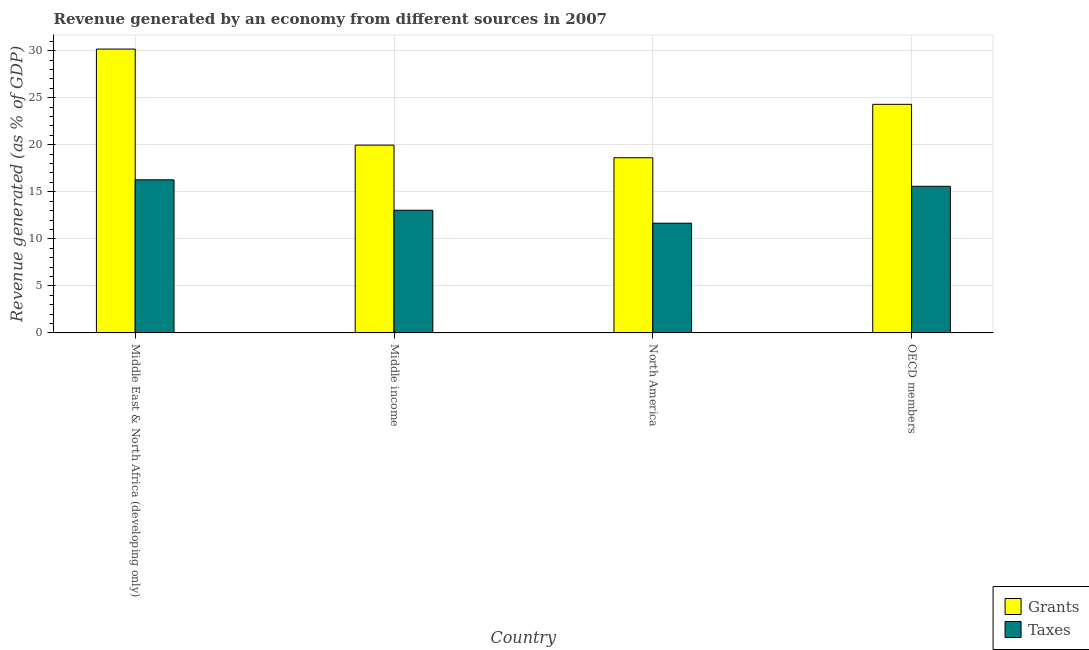How many bars are there on the 2nd tick from the right?
Make the answer very short. 2. In how many cases, is the number of bars for a given country not equal to the number of legend labels?
Ensure brevity in your answer.  0. What is the revenue generated by taxes in North America?
Offer a very short reply. 11.66. Across all countries, what is the maximum revenue generated by grants?
Make the answer very short. 30.17. Across all countries, what is the minimum revenue generated by grants?
Provide a succinct answer. 18.62. In which country was the revenue generated by grants maximum?
Your answer should be compact. Middle East & North Africa (developing only). What is the total revenue generated by taxes in the graph?
Give a very brief answer. 56.56. What is the difference between the revenue generated by taxes in North America and that in OECD members?
Give a very brief answer. -3.92. What is the difference between the revenue generated by grants in OECD members and the revenue generated by taxes in Middle East & North Africa (developing only)?
Offer a very short reply. 8.02. What is the average revenue generated by grants per country?
Your response must be concise. 23.26. What is the difference between the revenue generated by taxes and revenue generated by grants in OECD members?
Your answer should be very brief. -8.71. What is the ratio of the revenue generated by taxes in Middle income to that in North America?
Provide a short and direct response. 1.12. What is the difference between the highest and the second highest revenue generated by grants?
Your answer should be very brief. 5.87. What is the difference between the highest and the lowest revenue generated by grants?
Your answer should be compact. 11.55. Is the sum of the revenue generated by grants in Middle East & North Africa (developing only) and Middle income greater than the maximum revenue generated by taxes across all countries?
Offer a terse response. Yes. What does the 2nd bar from the left in Middle East & North Africa (developing only) represents?
Provide a short and direct response. Taxes. What does the 2nd bar from the right in OECD members represents?
Provide a short and direct response. Grants. How many bars are there?
Keep it short and to the point. 8. How many countries are there in the graph?
Make the answer very short. 4. Are the values on the major ticks of Y-axis written in scientific E-notation?
Make the answer very short. No. How many legend labels are there?
Your answer should be very brief. 2. How are the legend labels stacked?
Your answer should be compact. Vertical. What is the title of the graph?
Your answer should be compact. Revenue generated by an economy from different sources in 2007. Does "Study and work" appear as one of the legend labels in the graph?
Your response must be concise. No. What is the label or title of the Y-axis?
Provide a succinct answer. Revenue generated (as % of GDP). What is the Revenue generated (as % of GDP) in Grants in Middle East & North Africa (developing only)?
Your response must be concise. 30.17. What is the Revenue generated (as % of GDP) of Taxes in Middle East & North Africa (developing only)?
Keep it short and to the point. 16.27. What is the Revenue generated (as % of GDP) in Grants in Middle income?
Provide a succinct answer. 19.96. What is the Revenue generated (as % of GDP) of Taxes in Middle income?
Provide a succinct answer. 13.04. What is the Revenue generated (as % of GDP) in Grants in North America?
Give a very brief answer. 18.62. What is the Revenue generated (as % of GDP) in Taxes in North America?
Provide a succinct answer. 11.66. What is the Revenue generated (as % of GDP) of Grants in OECD members?
Your response must be concise. 24.3. What is the Revenue generated (as % of GDP) of Taxes in OECD members?
Ensure brevity in your answer.  15.58. Across all countries, what is the maximum Revenue generated (as % of GDP) of Grants?
Your response must be concise. 30.17. Across all countries, what is the maximum Revenue generated (as % of GDP) in Taxes?
Keep it short and to the point. 16.27. Across all countries, what is the minimum Revenue generated (as % of GDP) of Grants?
Offer a very short reply. 18.62. Across all countries, what is the minimum Revenue generated (as % of GDP) of Taxes?
Provide a short and direct response. 11.66. What is the total Revenue generated (as % of GDP) of Grants in the graph?
Offer a terse response. 93.04. What is the total Revenue generated (as % of GDP) of Taxes in the graph?
Provide a succinct answer. 56.56. What is the difference between the Revenue generated (as % of GDP) of Grants in Middle East & North Africa (developing only) and that in Middle income?
Your answer should be very brief. 10.21. What is the difference between the Revenue generated (as % of GDP) in Taxes in Middle East & North Africa (developing only) and that in Middle income?
Provide a succinct answer. 3.23. What is the difference between the Revenue generated (as % of GDP) in Grants in Middle East & North Africa (developing only) and that in North America?
Offer a very short reply. 11.55. What is the difference between the Revenue generated (as % of GDP) of Taxes in Middle East & North Africa (developing only) and that in North America?
Give a very brief answer. 4.61. What is the difference between the Revenue generated (as % of GDP) of Grants in Middle East & North Africa (developing only) and that in OECD members?
Keep it short and to the point. 5.87. What is the difference between the Revenue generated (as % of GDP) of Taxes in Middle East & North Africa (developing only) and that in OECD members?
Make the answer very short. 0.69. What is the difference between the Revenue generated (as % of GDP) in Grants in Middle income and that in North America?
Offer a terse response. 1.34. What is the difference between the Revenue generated (as % of GDP) in Taxes in Middle income and that in North America?
Your response must be concise. 1.38. What is the difference between the Revenue generated (as % of GDP) in Grants in Middle income and that in OECD members?
Keep it short and to the point. -4.34. What is the difference between the Revenue generated (as % of GDP) of Taxes in Middle income and that in OECD members?
Keep it short and to the point. -2.55. What is the difference between the Revenue generated (as % of GDP) of Grants in North America and that in OECD members?
Make the answer very short. -5.68. What is the difference between the Revenue generated (as % of GDP) of Taxes in North America and that in OECD members?
Give a very brief answer. -3.92. What is the difference between the Revenue generated (as % of GDP) of Grants in Middle East & North Africa (developing only) and the Revenue generated (as % of GDP) of Taxes in Middle income?
Make the answer very short. 17.13. What is the difference between the Revenue generated (as % of GDP) in Grants in Middle East & North Africa (developing only) and the Revenue generated (as % of GDP) in Taxes in North America?
Offer a terse response. 18.51. What is the difference between the Revenue generated (as % of GDP) of Grants in Middle East & North Africa (developing only) and the Revenue generated (as % of GDP) of Taxes in OECD members?
Your answer should be compact. 14.59. What is the difference between the Revenue generated (as % of GDP) in Grants in Middle income and the Revenue generated (as % of GDP) in Taxes in North America?
Keep it short and to the point. 8.3. What is the difference between the Revenue generated (as % of GDP) in Grants in Middle income and the Revenue generated (as % of GDP) in Taxes in OECD members?
Keep it short and to the point. 4.38. What is the difference between the Revenue generated (as % of GDP) of Grants in North America and the Revenue generated (as % of GDP) of Taxes in OECD members?
Make the answer very short. 3.04. What is the average Revenue generated (as % of GDP) of Grants per country?
Ensure brevity in your answer.  23.26. What is the average Revenue generated (as % of GDP) in Taxes per country?
Your answer should be very brief. 14.14. What is the difference between the Revenue generated (as % of GDP) in Grants and Revenue generated (as % of GDP) in Taxes in Middle East & North Africa (developing only)?
Keep it short and to the point. 13.9. What is the difference between the Revenue generated (as % of GDP) of Grants and Revenue generated (as % of GDP) of Taxes in Middle income?
Provide a succinct answer. 6.92. What is the difference between the Revenue generated (as % of GDP) in Grants and Revenue generated (as % of GDP) in Taxes in North America?
Make the answer very short. 6.96. What is the difference between the Revenue generated (as % of GDP) in Grants and Revenue generated (as % of GDP) in Taxes in OECD members?
Your answer should be compact. 8.71. What is the ratio of the Revenue generated (as % of GDP) in Grants in Middle East & North Africa (developing only) to that in Middle income?
Give a very brief answer. 1.51. What is the ratio of the Revenue generated (as % of GDP) in Taxes in Middle East & North Africa (developing only) to that in Middle income?
Your answer should be compact. 1.25. What is the ratio of the Revenue generated (as % of GDP) in Grants in Middle East & North Africa (developing only) to that in North America?
Offer a terse response. 1.62. What is the ratio of the Revenue generated (as % of GDP) of Taxes in Middle East & North Africa (developing only) to that in North America?
Provide a succinct answer. 1.4. What is the ratio of the Revenue generated (as % of GDP) of Grants in Middle East & North Africa (developing only) to that in OECD members?
Provide a succinct answer. 1.24. What is the ratio of the Revenue generated (as % of GDP) in Taxes in Middle East & North Africa (developing only) to that in OECD members?
Ensure brevity in your answer.  1.04. What is the ratio of the Revenue generated (as % of GDP) in Grants in Middle income to that in North America?
Provide a succinct answer. 1.07. What is the ratio of the Revenue generated (as % of GDP) of Taxes in Middle income to that in North America?
Provide a succinct answer. 1.12. What is the ratio of the Revenue generated (as % of GDP) of Grants in Middle income to that in OECD members?
Offer a very short reply. 0.82. What is the ratio of the Revenue generated (as % of GDP) of Taxes in Middle income to that in OECD members?
Your answer should be compact. 0.84. What is the ratio of the Revenue generated (as % of GDP) of Grants in North America to that in OECD members?
Your response must be concise. 0.77. What is the ratio of the Revenue generated (as % of GDP) of Taxes in North America to that in OECD members?
Offer a very short reply. 0.75. What is the difference between the highest and the second highest Revenue generated (as % of GDP) in Grants?
Make the answer very short. 5.87. What is the difference between the highest and the second highest Revenue generated (as % of GDP) of Taxes?
Your answer should be compact. 0.69. What is the difference between the highest and the lowest Revenue generated (as % of GDP) in Grants?
Ensure brevity in your answer.  11.55. What is the difference between the highest and the lowest Revenue generated (as % of GDP) of Taxes?
Provide a succinct answer. 4.61. 